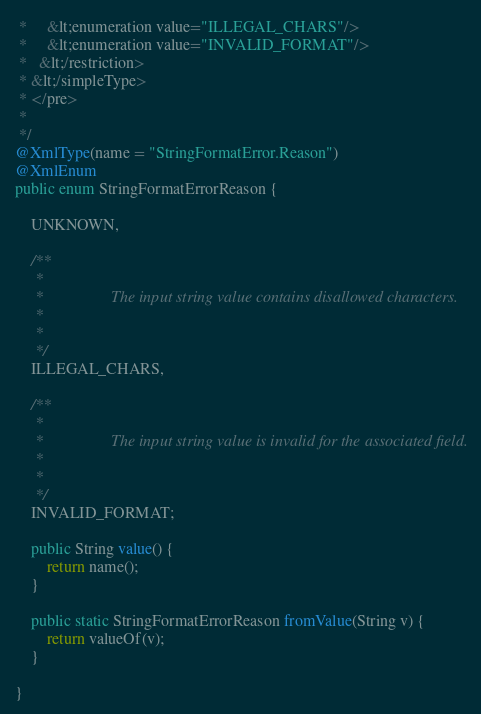Convert code to text. <code><loc_0><loc_0><loc_500><loc_500><_Java_> *     &lt;enumeration value="ILLEGAL_CHARS"/>
 *     &lt;enumeration value="INVALID_FORMAT"/>
 *   &lt;/restriction>
 * &lt;/simpleType>
 * </pre>
 * 
 */
@XmlType(name = "StringFormatError.Reason")
@XmlEnum
public enum StringFormatErrorReason {

    UNKNOWN,

    /**
     * 
     *                 The input string value contains disallowed characters.
     *               
     * 
     */
    ILLEGAL_CHARS,

    /**
     * 
     *                 The input string value is invalid for the associated field.
     *               
     * 
     */
    INVALID_FORMAT;

    public String value() {
        return name();
    }

    public static StringFormatErrorReason fromValue(String v) {
        return valueOf(v);
    }

}
</code> 